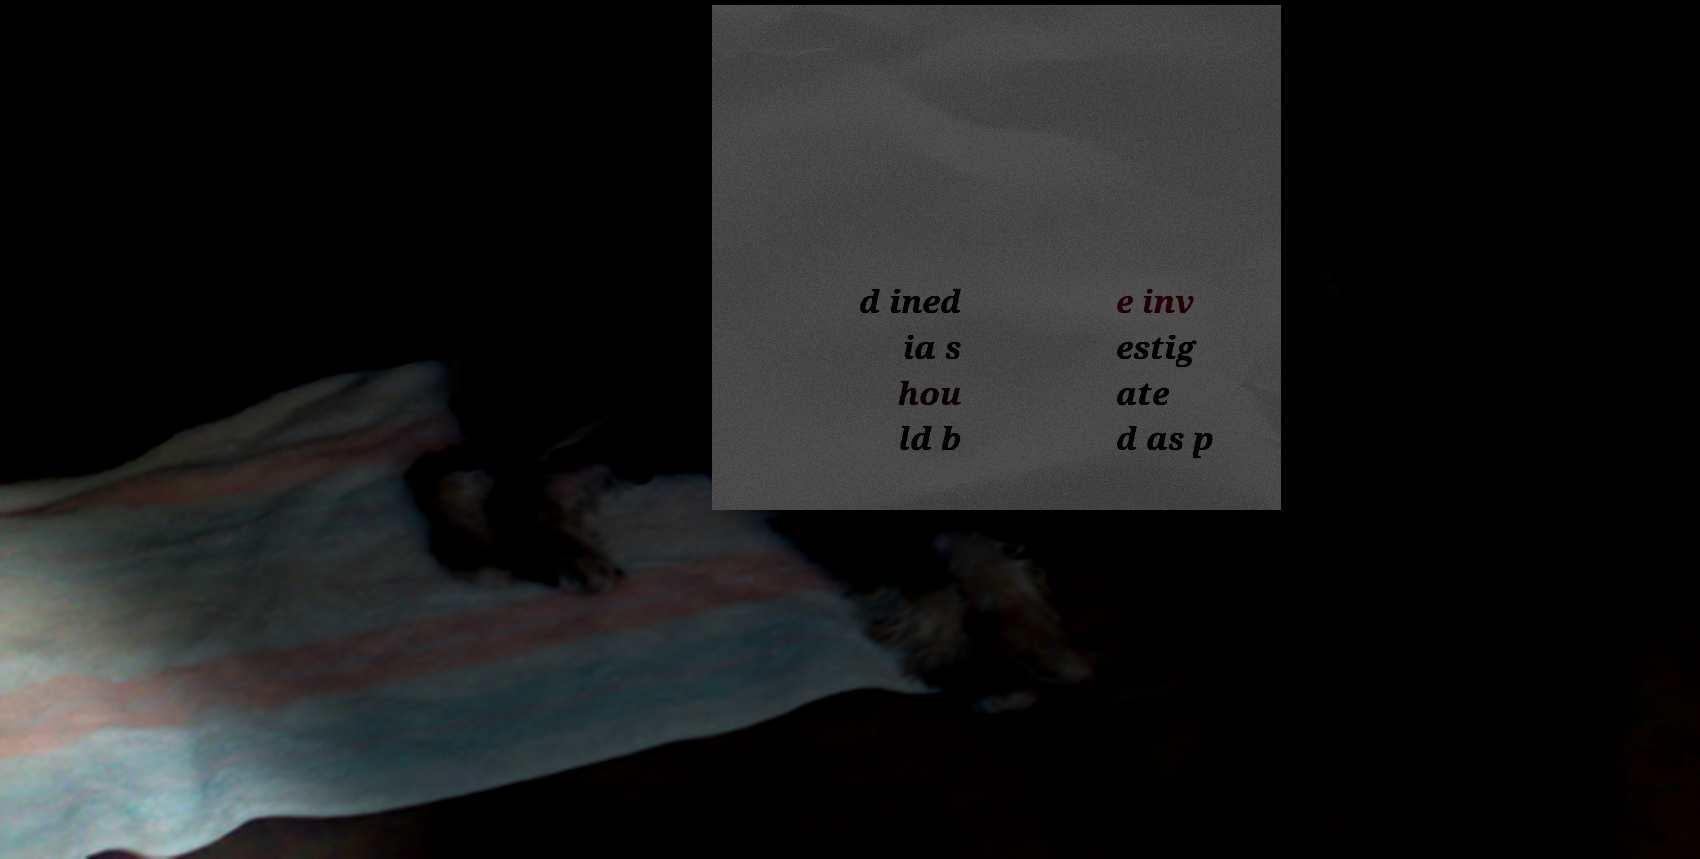For documentation purposes, I need the text within this image transcribed. Could you provide that? d ined ia s hou ld b e inv estig ate d as p 